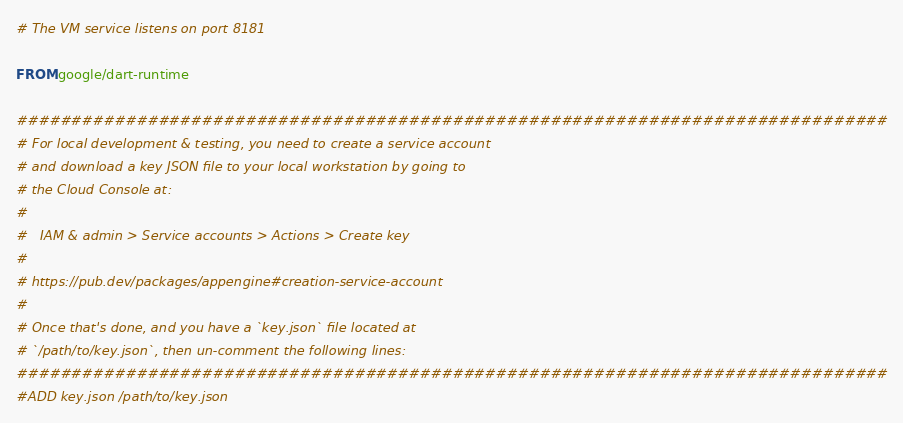Convert code to text. <code><loc_0><loc_0><loc_500><loc_500><_Dockerfile_># The VM service listens on port 8181

FROM google/dart-runtime

################################################################################
# For local development & testing, you need to create a service account
# and download a key JSON file to your local workstation by going to
# the Cloud Console at:
#
#   IAM & admin > Service accounts > Actions > Create key
#
# https://pub.dev/packages/appengine#creation-service-account
#
# Once that's done, and you have a `key.json` file located at
# `/path/to/key.json`, then un-comment the following lines:
################################################################################
#ADD key.json /path/to/key.json</code> 